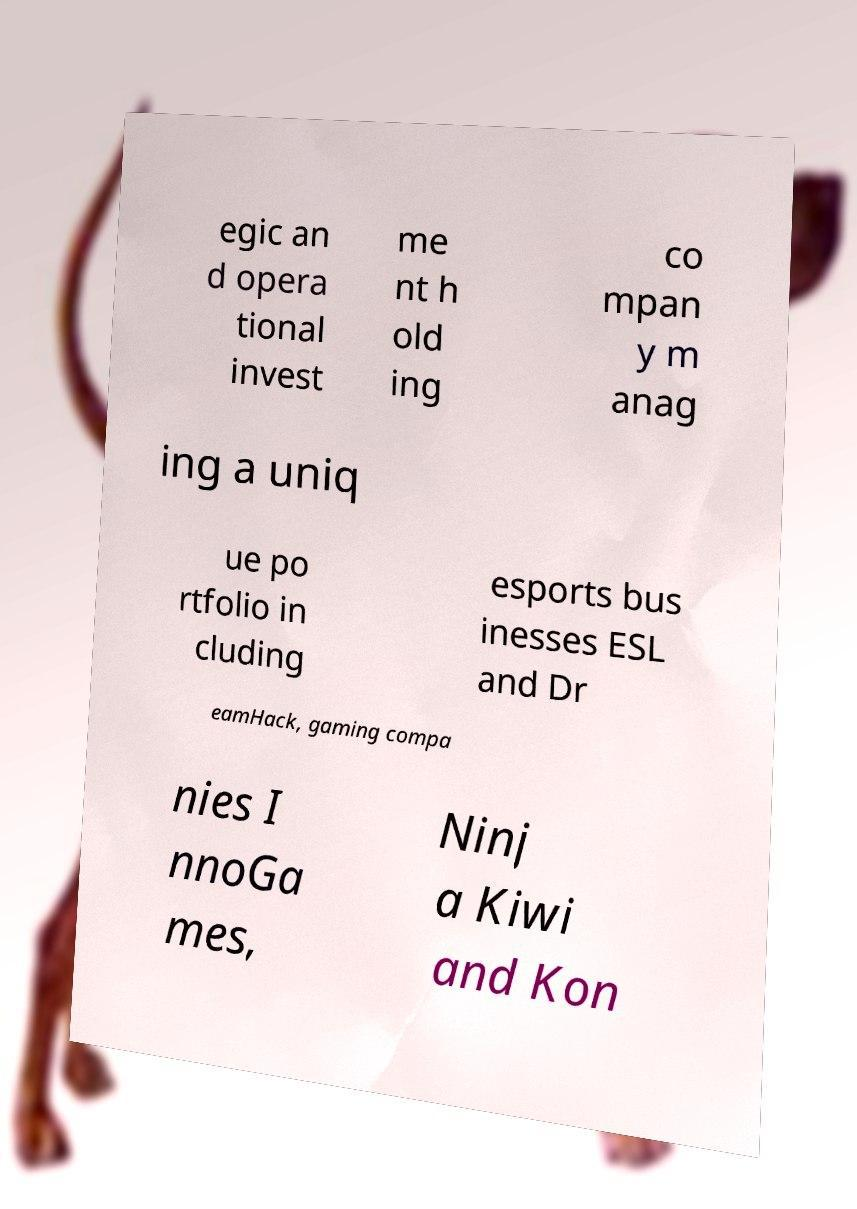Can you accurately transcribe the text from the provided image for me? egic an d opera tional invest me nt h old ing co mpan y m anag ing a uniq ue po rtfolio in cluding esports bus inesses ESL and Dr eamHack, gaming compa nies I nnoGa mes, Ninj a Kiwi and Kon 